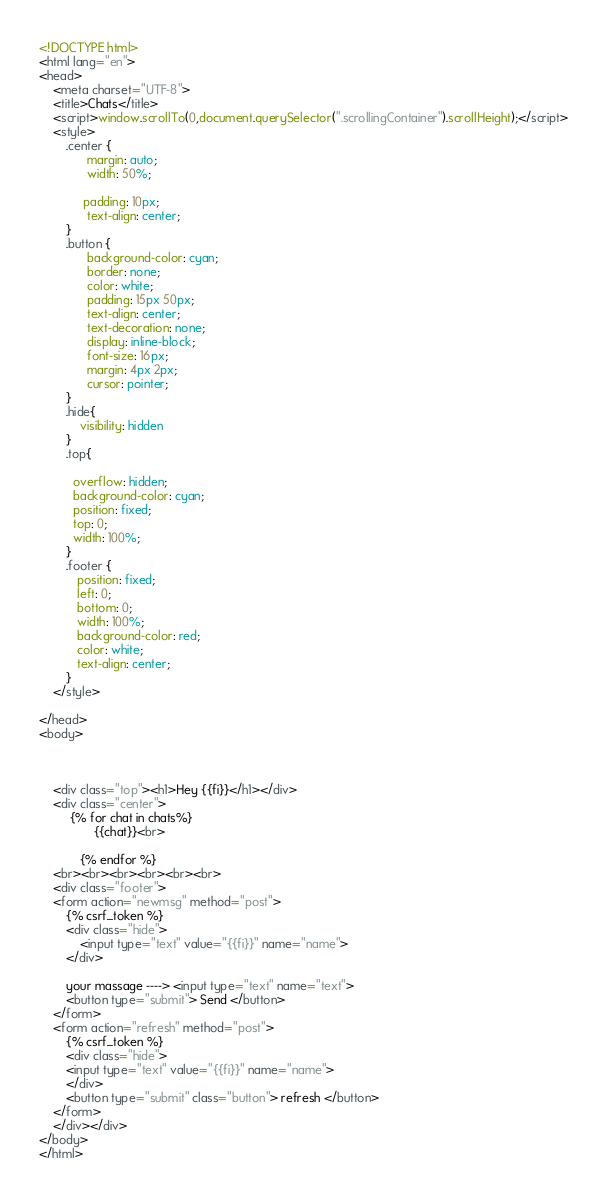Convert code to text. <code><loc_0><loc_0><loc_500><loc_500><_HTML_><!DOCTYPE html>
<html lang="en">
<head>
    <meta charset="UTF-8">
    <title>Chats</title>
    <script>window.scrollTo(0,document.querySelector(".scrollingContainer").scrollHeight);</script>
    <style>
        .center {
              margin: auto;
              width: 50%;

             padding: 10px;
              text-align: center;
        }
        .button {
              background-color: cyan;
              border: none;
              color: white;
              padding: 15px 50px;
              text-align: center;
              text-decoration: none;
              display: inline-block;
              font-size: 16px;
              margin: 4px 2px;
              cursor: pointer;
        }
        .hide{
            visibility: hidden
        }
        .top{

          overflow: hidden;
          background-color: cyan;
          position: fixed;
          top: 0;
          width: 100%;
        }
        .footer {
           position: fixed;
           left: 0;
           bottom: 0;
           width: 100%;
           background-color: red;
           color: white;
           text-align: center;
        }
    </style>

</head>
<body>



    <div class="top"><h1>Hey {{fi}}</h1></div>
    <div class="center">
         {% for chat in chats%}
                {{chat}}<br>

            {% endfor %}
    <br><br><br><br><br><br>
    <div class="footer">
    <form action="newmsg" method="post">
        {% csrf_token %}
        <div class="hide">
            <input type="text" value="{{fi}}" name="name">
        </div>

        your massage ----> <input type="text" name="text">
        <button type="submit"> Send </button>
    </form>
    <form action="refresh" method="post">
        {% csrf_token %}
        <div class="hide">
        <input type="text" value="{{fi}}" name="name">
        </div>
        <button type="submit" class="button"> refresh </button>
    </form>
    </div></div>
</body>
</html></code> 